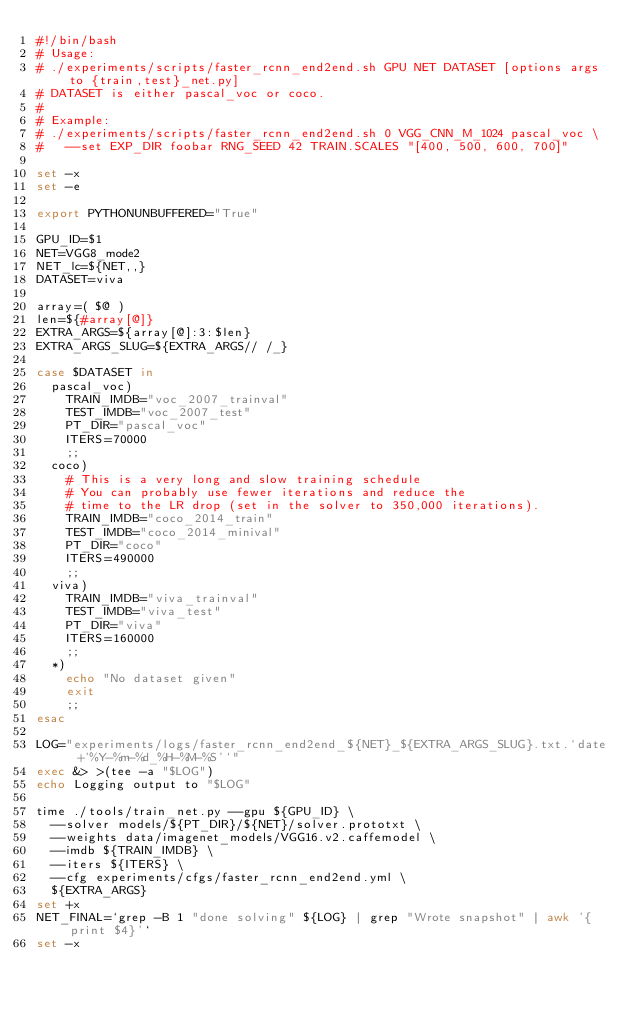Convert code to text. <code><loc_0><loc_0><loc_500><loc_500><_Bash_>#!/bin/bash
# Usage:
# ./experiments/scripts/faster_rcnn_end2end.sh GPU NET DATASET [options args to {train,test}_net.py]
# DATASET is either pascal_voc or coco.
#
# Example:
# ./experiments/scripts/faster_rcnn_end2end.sh 0 VGG_CNN_M_1024 pascal_voc \
#   --set EXP_DIR foobar RNG_SEED 42 TRAIN.SCALES "[400, 500, 600, 700]"

set -x
set -e

export PYTHONUNBUFFERED="True"

GPU_ID=$1
NET=VGG8_mode2
NET_lc=${NET,,}
DATASET=viva

array=( $@ )
len=${#array[@]}
EXTRA_ARGS=${array[@]:3:$len}
EXTRA_ARGS_SLUG=${EXTRA_ARGS// /_}

case $DATASET in
  pascal_voc)
    TRAIN_IMDB="voc_2007_trainval"
    TEST_IMDB="voc_2007_test"
    PT_DIR="pascal_voc"
    ITERS=70000
    ;;
  coco)
    # This is a very long and slow training schedule
    # You can probably use fewer iterations and reduce the
    # time to the LR drop (set in the solver to 350,000 iterations).
    TRAIN_IMDB="coco_2014_train"
    TEST_IMDB="coco_2014_minival"
    PT_DIR="coco"
    ITERS=490000
    ;;
  viva)
    TRAIN_IMDB="viva_trainval"
    TEST_IMDB="viva_test"
    PT_DIR="viva"
    ITERS=160000
    ;;
  *)
    echo "No dataset given"
    exit
    ;;
esac

LOG="experiments/logs/faster_rcnn_end2end_${NET}_${EXTRA_ARGS_SLUG}.txt.`date +'%Y-%m-%d_%H-%M-%S'`"
exec &> >(tee -a "$LOG")
echo Logging output to "$LOG"

time ./tools/train_net.py --gpu ${GPU_ID} \
  --solver models/${PT_DIR}/${NET}/solver.prototxt \
  --weights data/imagenet_models/VGG16.v2.caffemodel \
  --imdb ${TRAIN_IMDB} \
  --iters ${ITERS} \
  --cfg experiments/cfgs/faster_rcnn_end2end.yml \
  ${EXTRA_ARGS}
set +x
NET_FINAL=`grep -B 1 "done solving" ${LOG} | grep "Wrote snapshot" | awk '{print $4}'`
set -x
</code> 